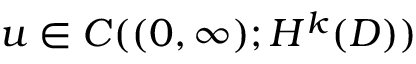<formula> <loc_0><loc_0><loc_500><loc_500>u \in C ( ( 0 , \infty ) ; H ^ { k } ( D ) )</formula> 